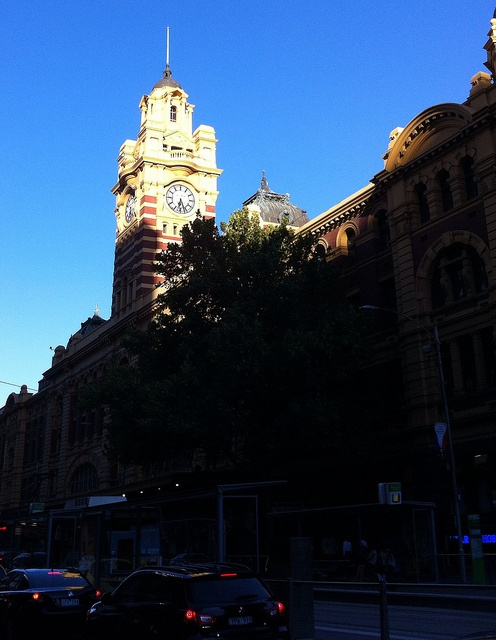Describe the objects in this image and their specific colors. I can see car in blue, black, navy, maroon, and gray tones, car in blue, black, and navy tones, clock in blue, white, darkgray, and gray tones, and clock in blue, lightgray, darkgray, and gray tones in this image. 